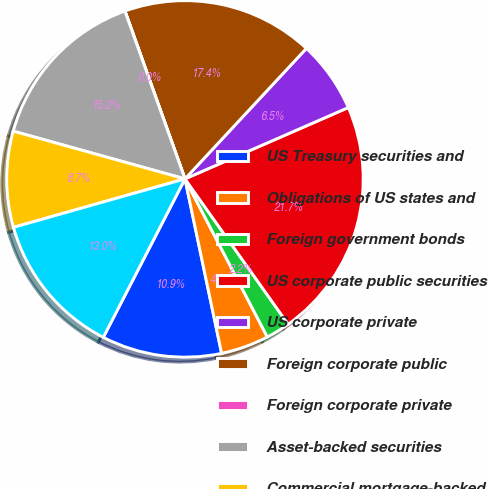Convert chart. <chart><loc_0><loc_0><loc_500><loc_500><pie_chart><fcel>US Treasury securities and<fcel>Obligations of US states and<fcel>Foreign government bonds<fcel>US corporate public securities<fcel>US corporate private<fcel>Foreign corporate public<fcel>Foreign corporate private<fcel>Asset-backed securities<fcel>Commercial mortgage-backed<fcel>Residential mortgage-backed<nl><fcel>10.87%<fcel>4.35%<fcel>2.18%<fcel>21.73%<fcel>6.52%<fcel>17.39%<fcel>0.01%<fcel>15.21%<fcel>8.7%<fcel>13.04%<nl></chart> 